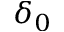<formula> <loc_0><loc_0><loc_500><loc_500>\delta _ { 0 }</formula> 